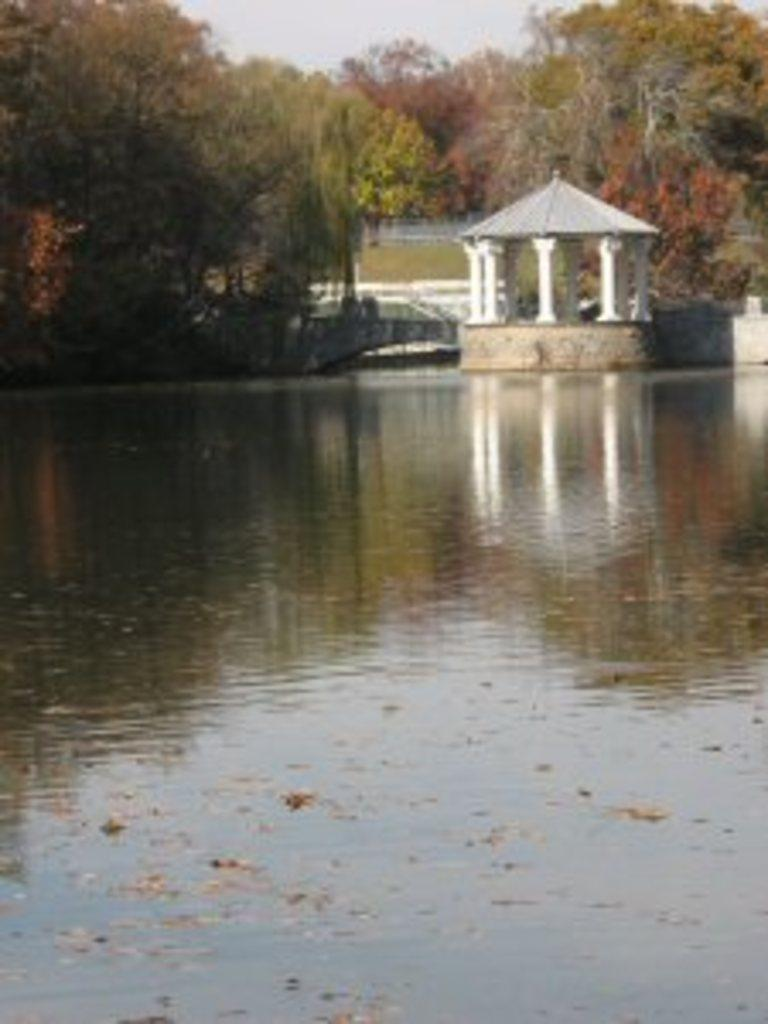What is visible in the image? Water is visible in the image. What can be seen in the background of the image? There are trees in the background of the image. What does the dad feel about the wall in the image? There is no dad or wall present in the image, so it is not possible to answer that question. 